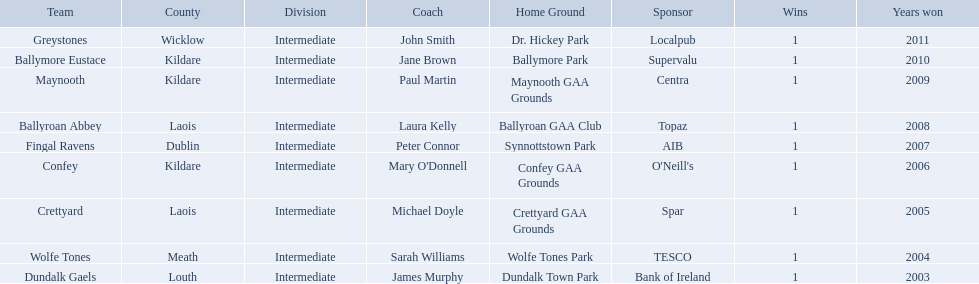What county is ballymore eustace from? Kildare. Besides convey, which other team is from the same county? Maynooth. Where is ballymore eustace from? Kildare. What teams other than ballymore eustace is from kildare? Maynooth, Confey. Between maynooth and confey, which won in 2009? Maynooth. 